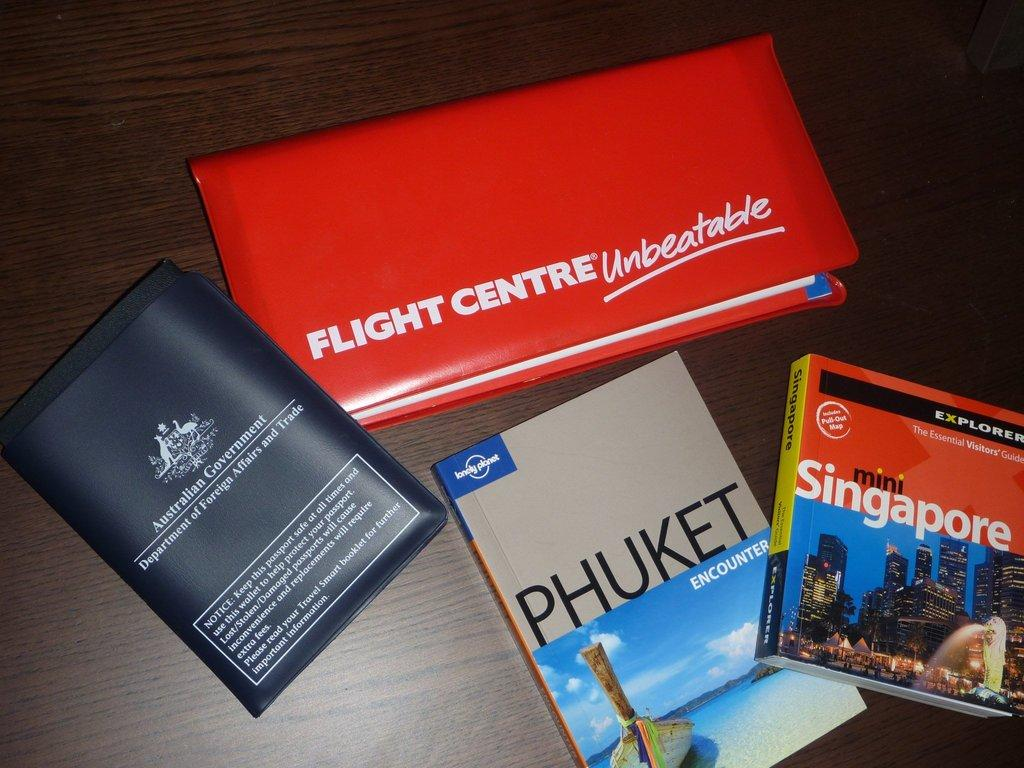<image>
Write a terse but informative summary of the picture. Four information pamphlets with one saying "Flight Centre". 